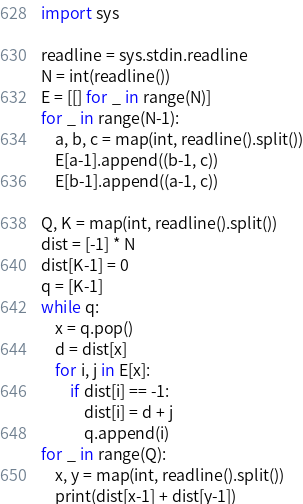<code> <loc_0><loc_0><loc_500><loc_500><_Python_>import sys

readline = sys.stdin.readline
N = int(readline())
E = [[] for _ in range(N)]
for _ in range(N-1):
    a, b, c = map(int, readline().split())
    E[a-1].append((b-1, c))
    E[b-1].append((a-1, c))

Q, K = map(int, readline().split())
dist = [-1] * N
dist[K-1] = 0
q = [K-1]
while q:
    x = q.pop()
    d = dist[x]
    for i, j in E[x]:
        if dist[i] == -1:
            dist[i] = d + j
            q.append(i)
for _ in range(Q):
    x, y = map(int, readline().split())
    print(dist[x-1] + dist[y-1])
</code> 